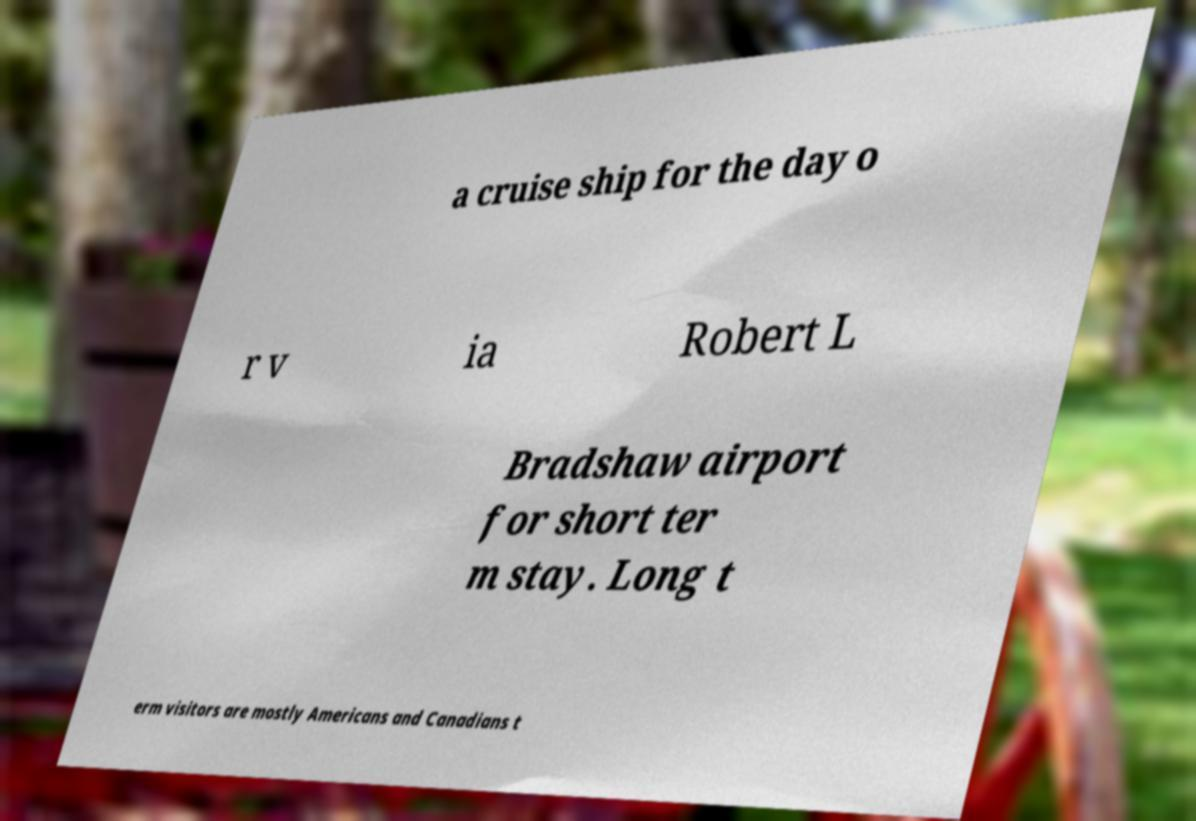There's text embedded in this image that I need extracted. Can you transcribe it verbatim? a cruise ship for the day o r v ia Robert L Bradshaw airport for short ter m stay. Long t erm visitors are mostly Americans and Canadians t 